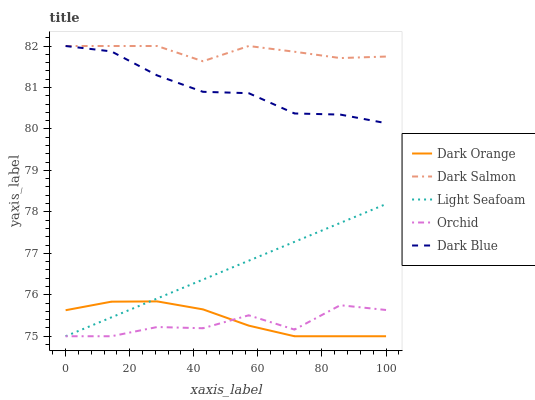Does Orchid have the minimum area under the curve?
Answer yes or no. Yes. Does Dark Salmon have the maximum area under the curve?
Answer yes or no. Yes. Does Dark Blue have the minimum area under the curve?
Answer yes or no. No. Does Dark Blue have the maximum area under the curve?
Answer yes or no. No. Is Light Seafoam the smoothest?
Answer yes or no. Yes. Is Orchid the roughest?
Answer yes or no. Yes. Is Dark Blue the smoothest?
Answer yes or no. No. Is Dark Blue the roughest?
Answer yes or no. No. Does Dark Orange have the lowest value?
Answer yes or no. Yes. Does Dark Blue have the lowest value?
Answer yes or no. No. Does Dark Salmon have the highest value?
Answer yes or no. Yes. Does Light Seafoam have the highest value?
Answer yes or no. No. Is Dark Orange less than Dark Blue?
Answer yes or no. Yes. Is Dark Blue greater than Orchid?
Answer yes or no. Yes. Does Dark Blue intersect Dark Salmon?
Answer yes or no. Yes. Is Dark Blue less than Dark Salmon?
Answer yes or no. No. Is Dark Blue greater than Dark Salmon?
Answer yes or no. No. Does Dark Orange intersect Dark Blue?
Answer yes or no. No. 